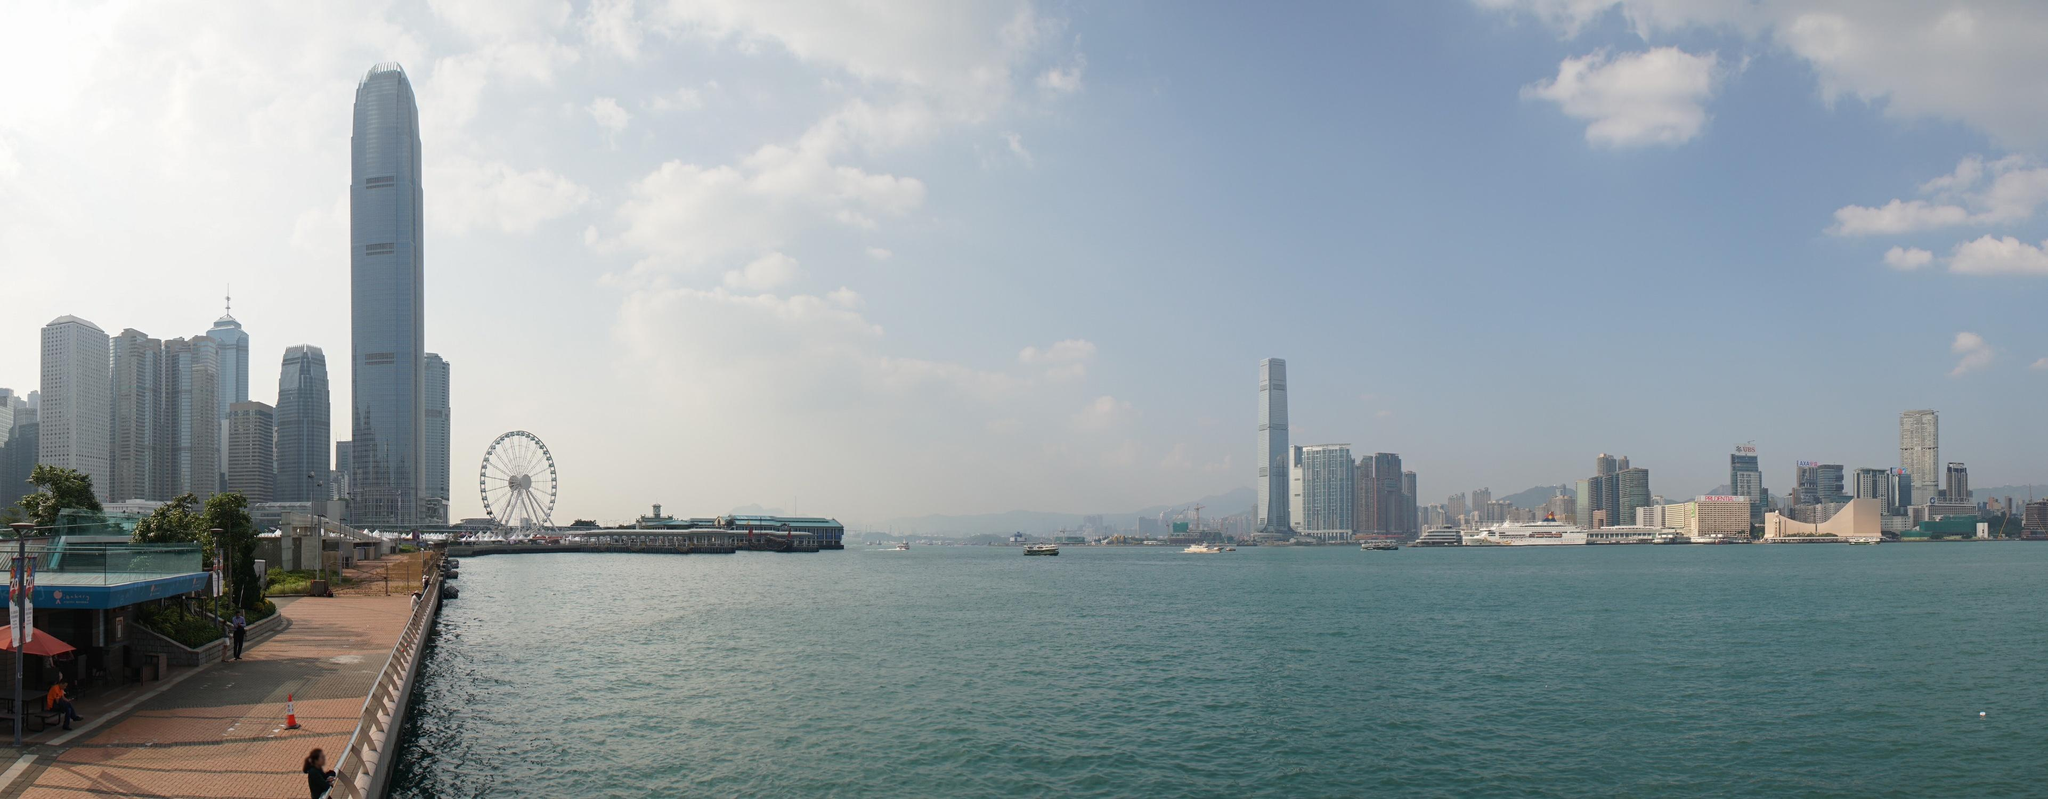Can you describe the atmosphere of the waterfront in the image? The atmosphere at the waterfront in this image is a harmonious blend of serenity and urban vibrancy. The clear, calming blue water of the harbor creates a serene backdrop against the bustling cityscape. The presence of people leisurely walking along the promenade suggests a relaxed environment, while the towering skyscrapers and the ferris wheel in the background evoke a sense of excitement and adventure. Overall, the scene depicts a tranquil yet lively atmosphere, perfect for a leisurely stroll or enjoying the city's bustling life from a distance. What kind of activities might people be engaging in along this waterfront? Along this waterfront, you can imagine a variety of activities taking place. People might be enjoying a casual walk, taking in the breathtaking views of the skyline and harbor. Others could be sitting on benches, chatting with friends, or possibly reading a book. Joggers or cyclists might pass by, as the wide, paved path is perfect for such activities. The nearby ferris wheel suggests a family-friendly spot where parents might be taking their children for some fun rides. Photographers could be seen capturing the stunning cityscape, while tourists possibly engage in sightseeing or taking selfies to remember their visit. 